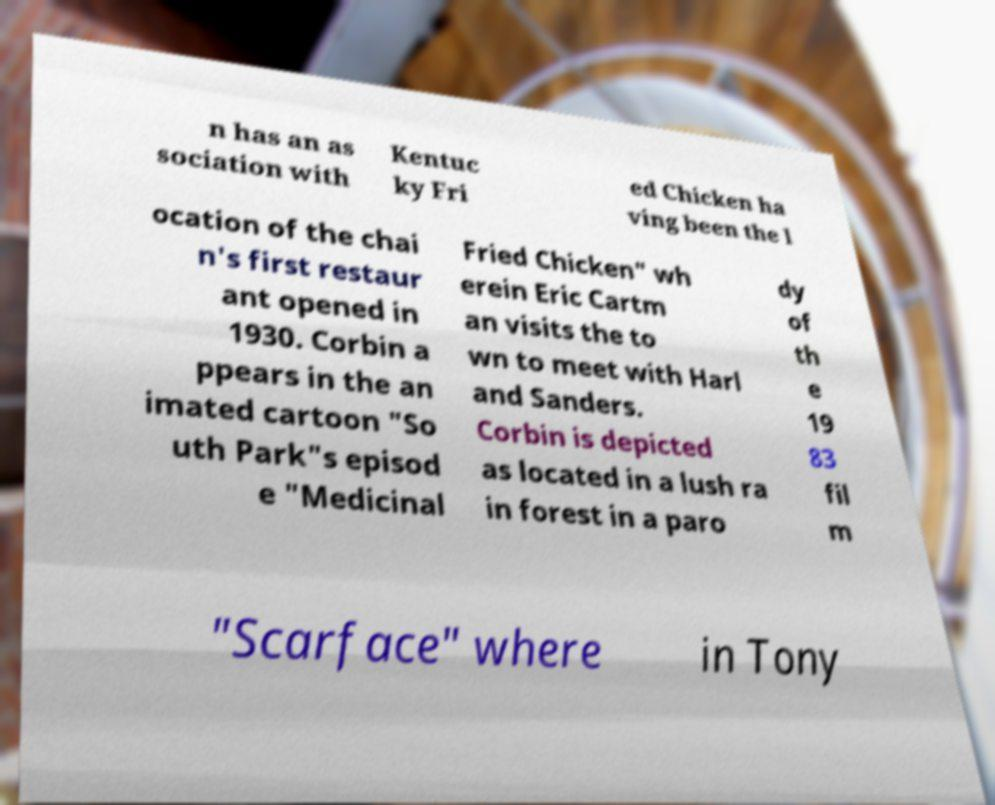I need the written content from this picture converted into text. Can you do that? n has an as sociation with Kentuc ky Fri ed Chicken ha ving been the l ocation of the chai n's first restaur ant opened in 1930. Corbin a ppears in the an imated cartoon "So uth Park"s episod e "Medicinal Fried Chicken" wh erein Eric Cartm an visits the to wn to meet with Harl and Sanders. Corbin is depicted as located in a lush ra in forest in a paro dy of th e 19 83 fil m "Scarface" where in Tony 